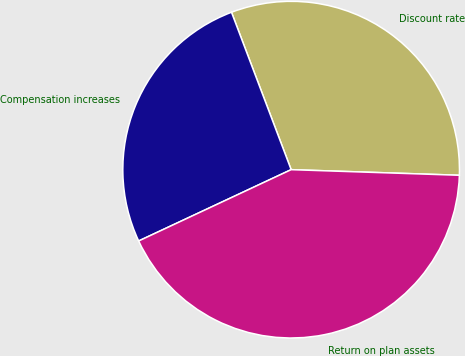<chart> <loc_0><loc_0><loc_500><loc_500><pie_chart><fcel>Discount rate<fcel>Compensation increases<fcel>Return on plan assets<nl><fcel>31.3%<fcel>26.2%<fcel>42.51%<nl></chart> 